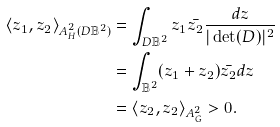<formula> <loc_0><loc_0><loc_500><loc_500>\langle z _ { 1 } , z _ { 2 } \rangle _ { A _ { H } ^ { 2 } ( D \mathbb { B } ^ { 2 } ) } & = \int _ { D \mathbb { B } ^ { 2 } } z _ { 1 } \bar { z _ { 2 } } \frac { d z } { | \det ( D ) | ^ { 2 } } \\ & = \int _ { \mathbb { B } ^ { 2 } } ( z _ { 1 } + z _ { 2 } ) \bar { z _ { 2 } } d z \\ & = \langle z _ { 2 } , z _ { 2 } \rangle _ { A _ { G } ^ { 2 } } > 0 .</formula> 